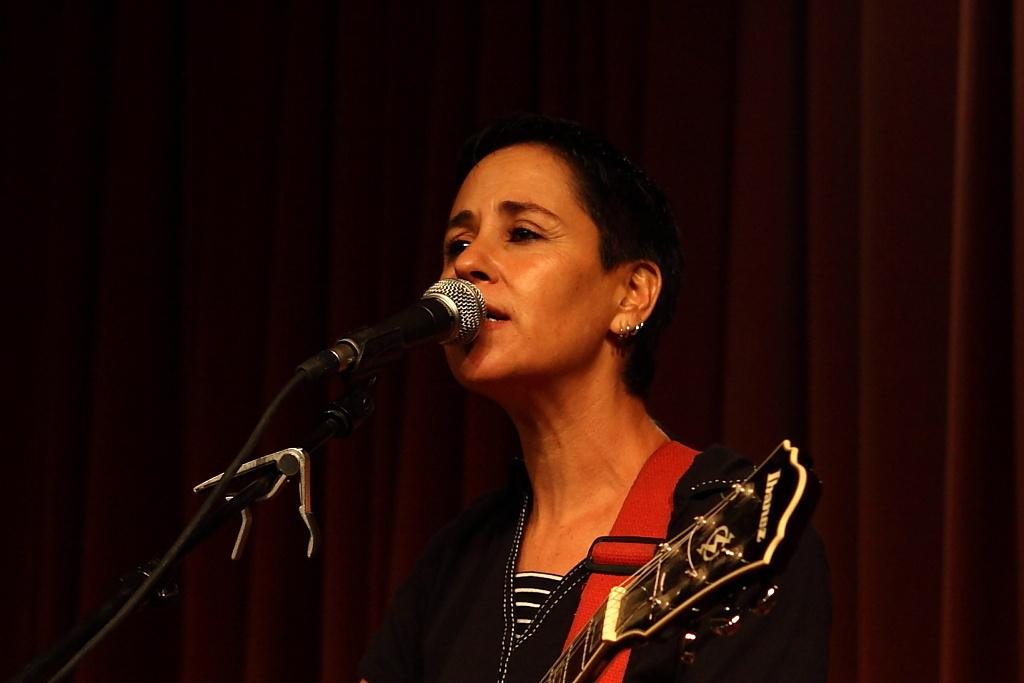What is the woman doing in the image? She is singing a song. What instrument is she holding? She is holding a guitar. What can be seen in the background behind her? There is a black color curtain and a microphone in the background. What type of gun is the woman holding in the image? There is no gun present in the image; she is holding a guitar. Who is the woman's partner in the image? There is no partner mentioned or visible in the image. 